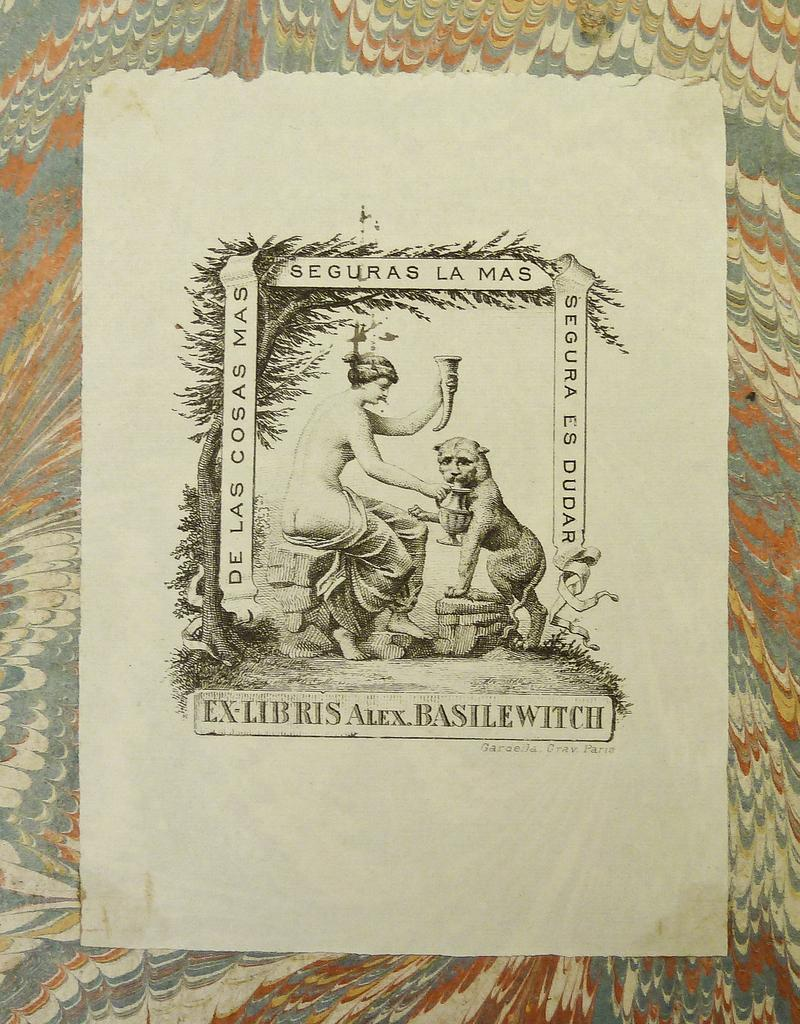<image>
Write a terse but informative summary of the picture. A picture of a naked woman and an animal has the words seguras la mas across the top. 